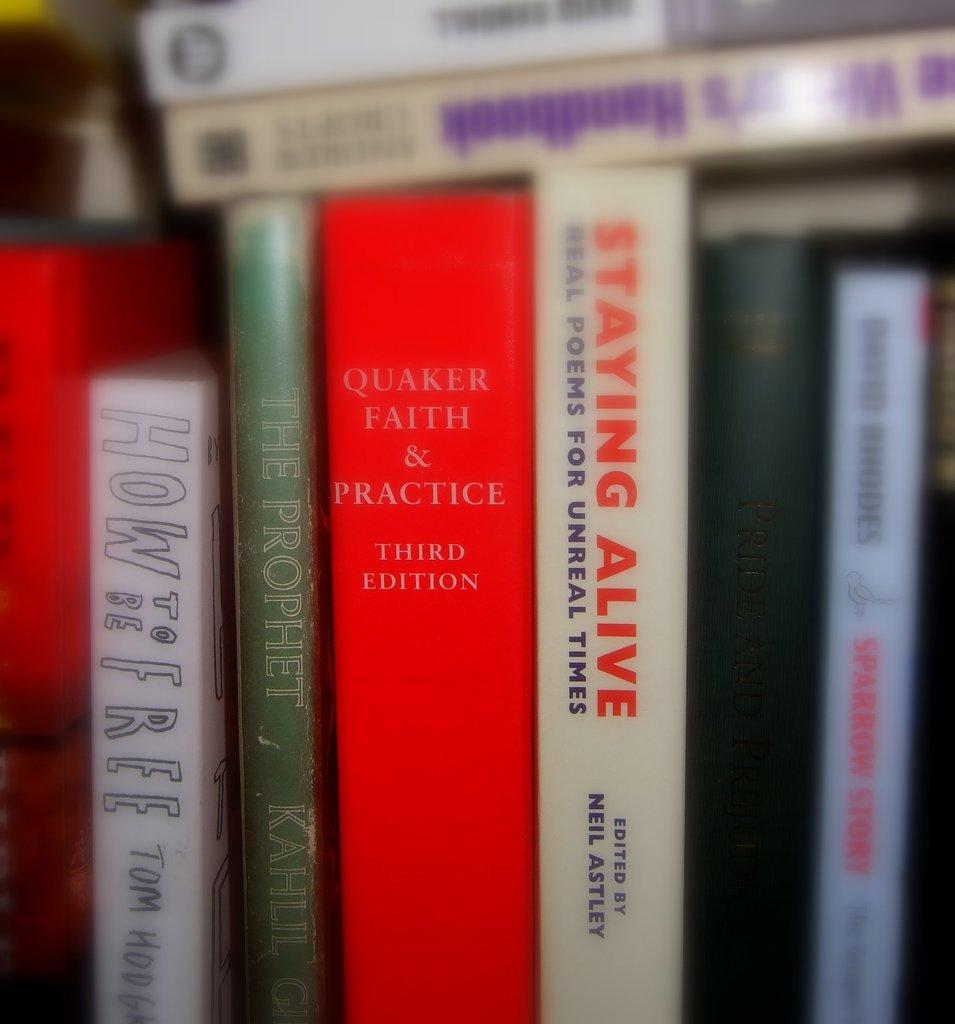<image>
Give a short and clear explanation of the subsequent image. Many books, including How To Be Free, line a shelf 